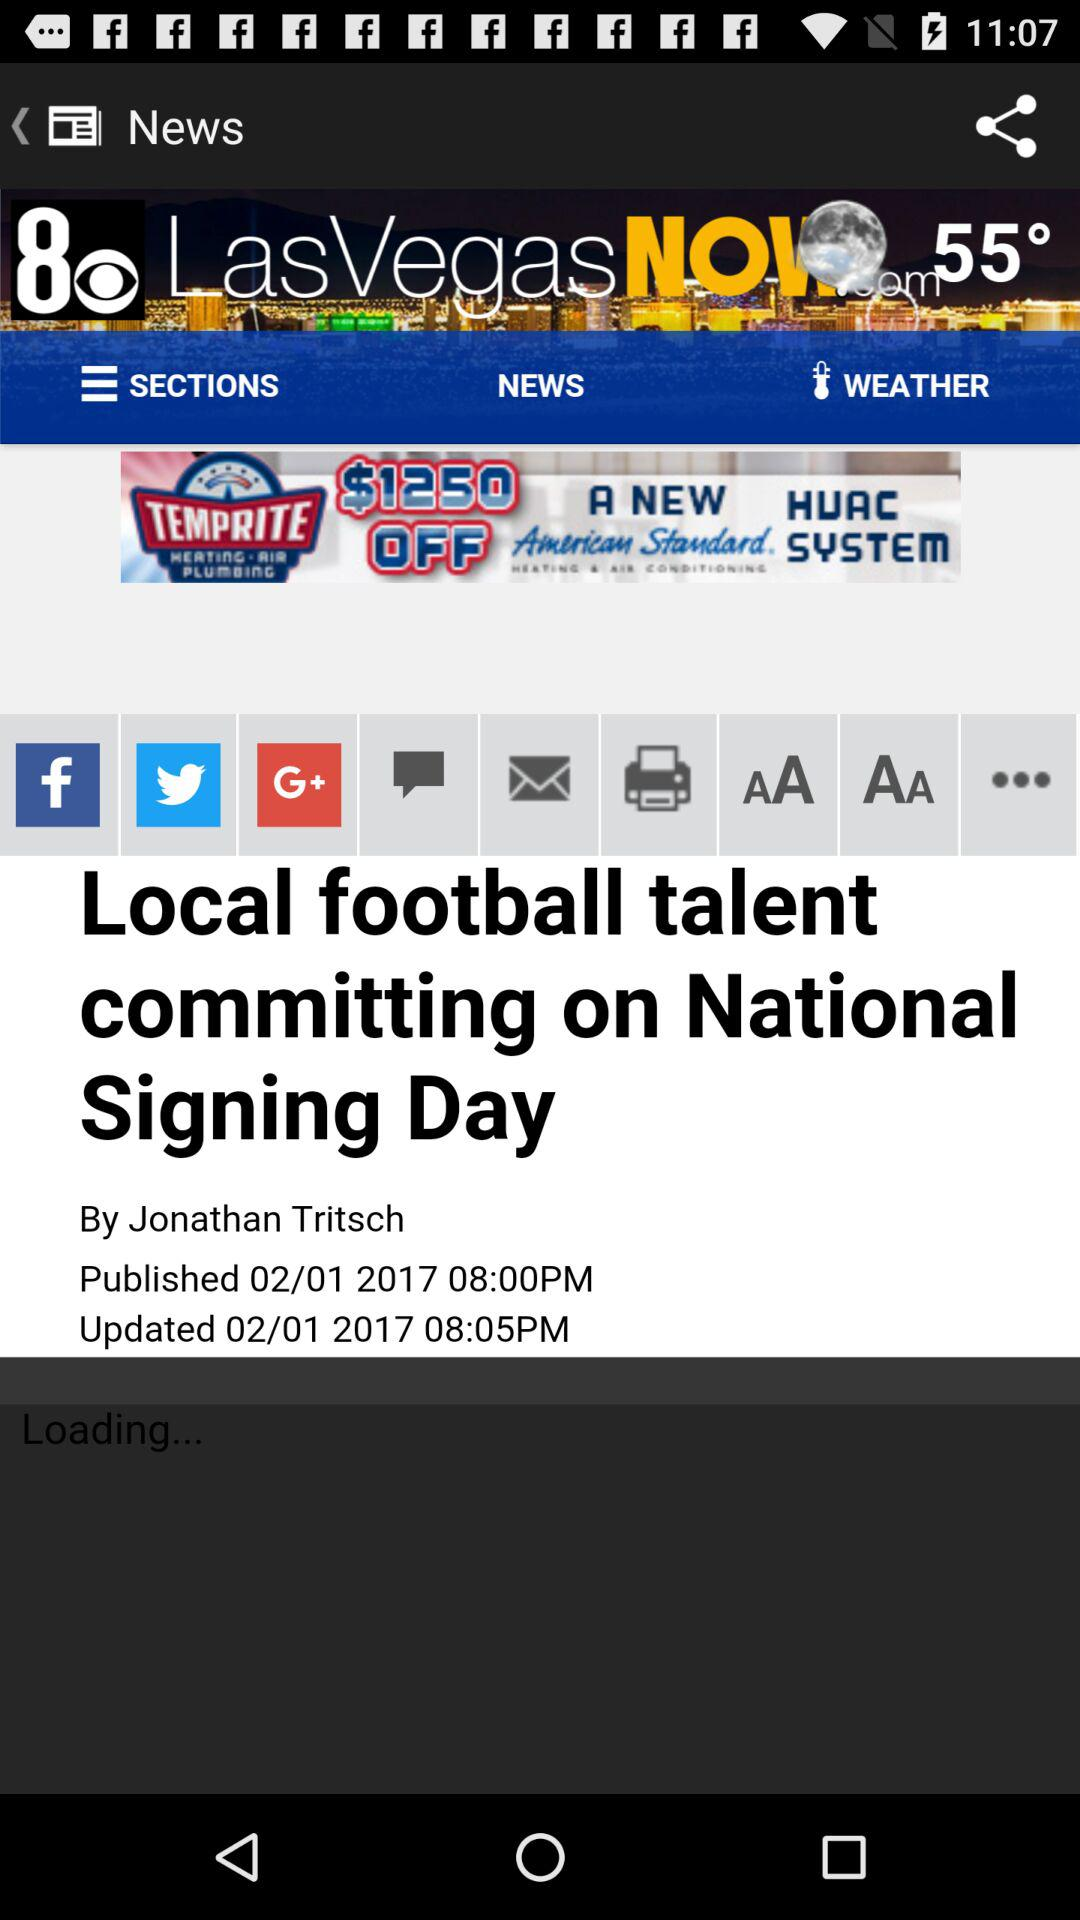When is the local football talent committing? It is on National Signing Day. 